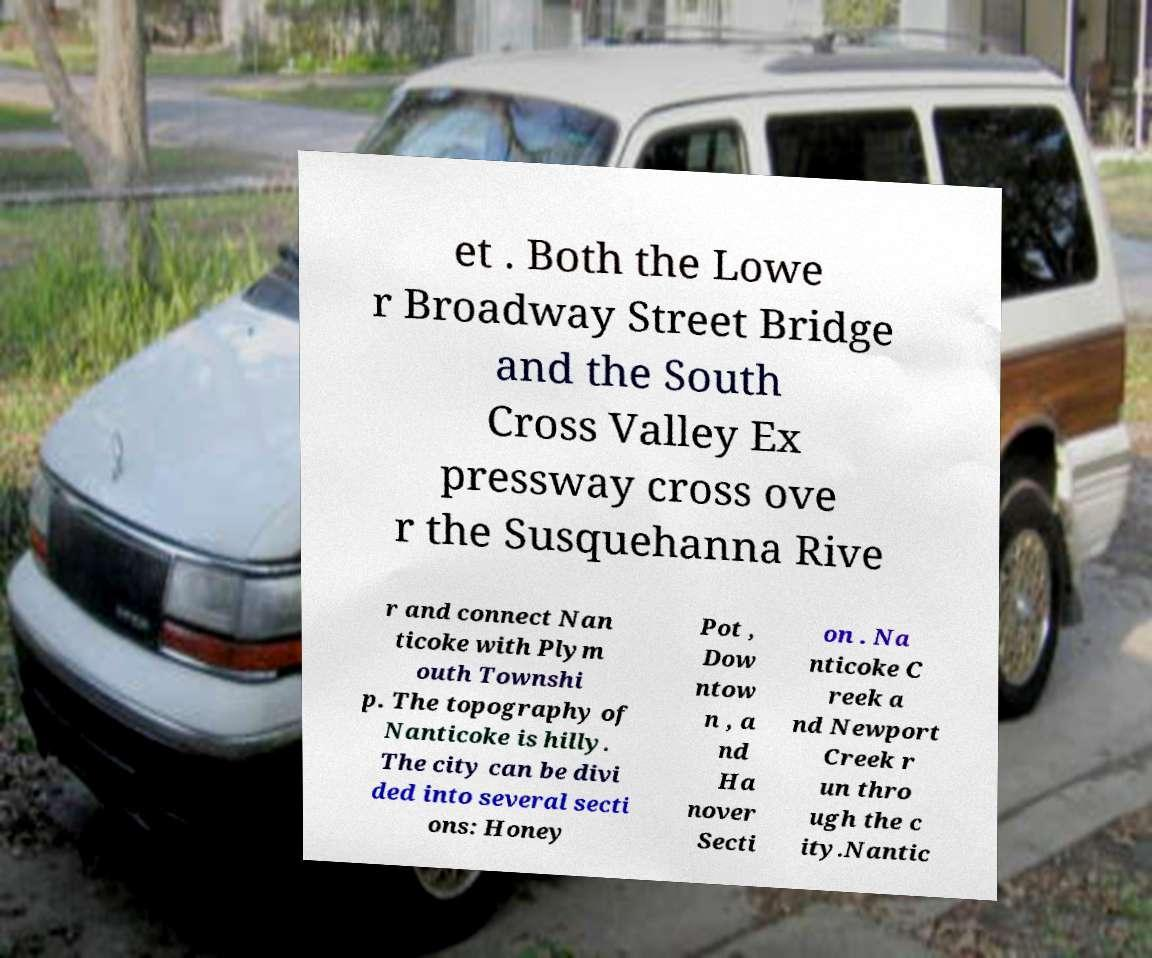There's text embedded in this image that I need extracted. Can you transcribe it verbatim? et . Both the Lowe r Broadway Street Bridge and the South Cross Valley Ex pressway cross ove r the Susquehanna Rive r and connect Nan ticoke with Plym outh Townshi p. The topography of Nanticoke is hilly. The city can be divi ded into several secti ons: Honey Pot , Dow ntow n , a nd Ha nover Secti on . Na nticoke C reek a nd Newport Creek r un thro ugh the c ity.Nantic 